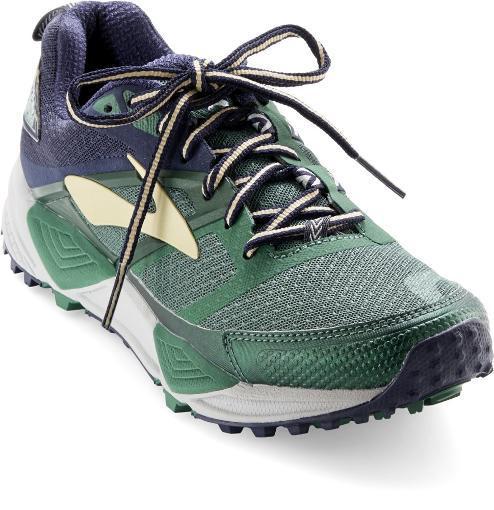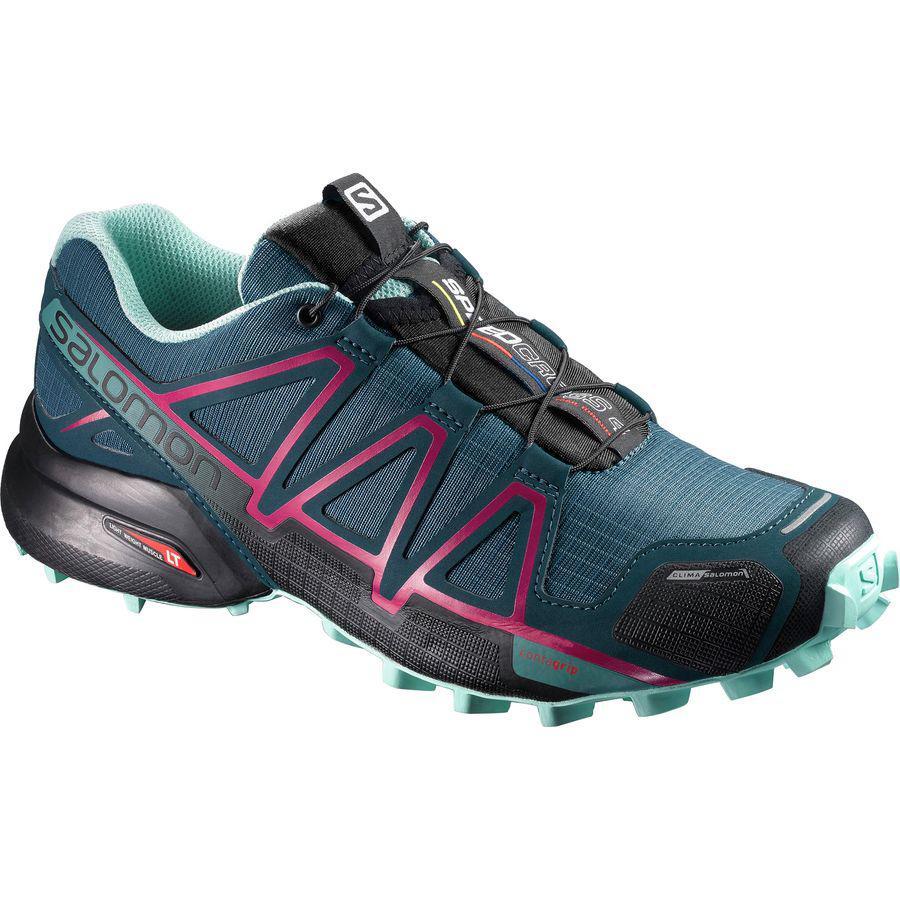The first image is the image on the left, the second image is the image on the right. Analyze the images presented: Is the assertion "One of the shoes has the laces tied in a bow." valid? Answer yes or no. Yes. The first image is the image on the left, the second image is the image on the right. Given the left and right images, does the statement "The shoe on the left has laces tied into a bow while the shoe on the right has laces that tighten without tying." hold true? Answer yes or no. Yes. 